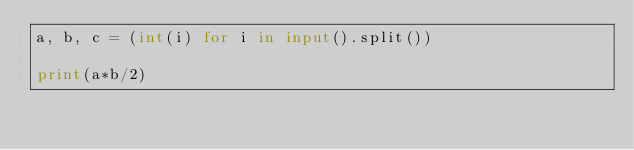Convert code to text. <code><loc_0><loc_0><loc_500><loc_500><_Python_>a, b, c = (int(i) for i in input().split())

print(a*b/2)</code> 